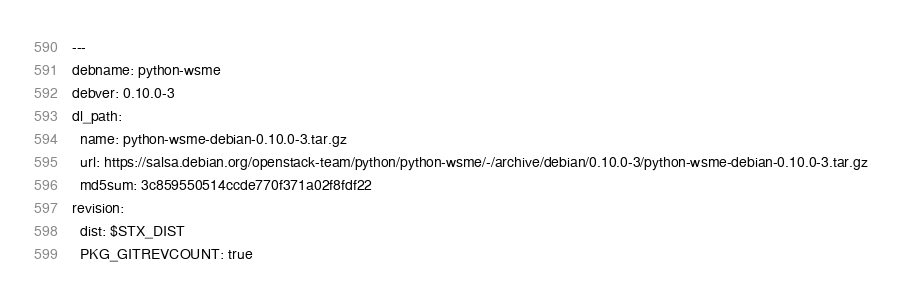Convert code to text. <code><loc_0><loc_0><loc_500><loc_500><_YAML_>---
debname: python-wsme
debver: 0.10.0-3
dl_path:
  name: python-wsme-debian-0.10.0-3.tar.gz
  url: https://salsa.debian.org/openstack-team/python/python-wsme/-/archive/debian/0.10.0-3/python-wsme-debian-0.10.0-3.tar.gz
  md5sum: 3c859550514ccde770f371a02f8fdf22
revision:
  dist: $STX_DIST
  PKG_GITREVCOUNT: true
</code> 